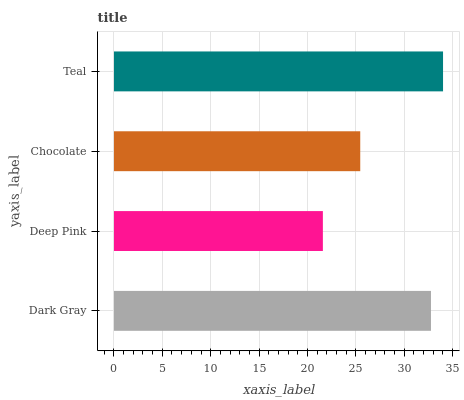Is Deep Pink the minimum?
Answer yes or no. Yes. Is Teal the maximum?
Answer yes or no. Yes. Is Chocolate the minimum?
Answer yes or no. No. Is Chocolate the maximum?
Answer yes or no. No. Is Chocolate greater than Deep Pink?
Answer yes or no. Yes. Is Deep Pink less than Chocolate?
Answer yes or no. Yes. Is Deep Pink greater than Chocolate?
Answer yes or no. No. Is Chocolate less than Deep Pink?
Answer yes or no. No. Is Dark Gray the high median?
Answer yes or no. Yes. Is Chocolate the low median?
Answer yes or no. Yes. Is Teal the high median?
Answer yes or no. No. Is Teal the low median?
Answer yes or no. No. 